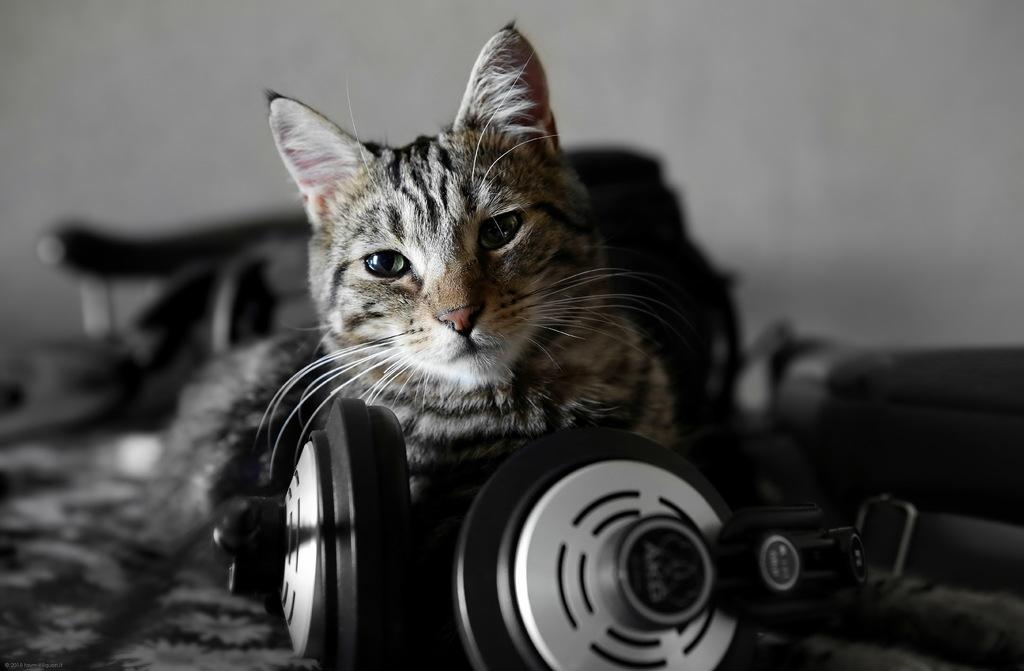What animal is laying on the floor in the image? There is a cat laying on the floor in the image. What is located in front of the cat? The cat is in front of a headset. What can be seen behind the cat? There is a wall visible in the image. What is on the wall? There are objects on the wall. How is the image presented? The image is in black and white. Can you see any cherries hanging from the wall in the image? There are no cherries present in the image. Is there a cemetery visible in the background of the image? There is no cemetery visible in the image; it features a cat, a headset, and a wall with objects. 